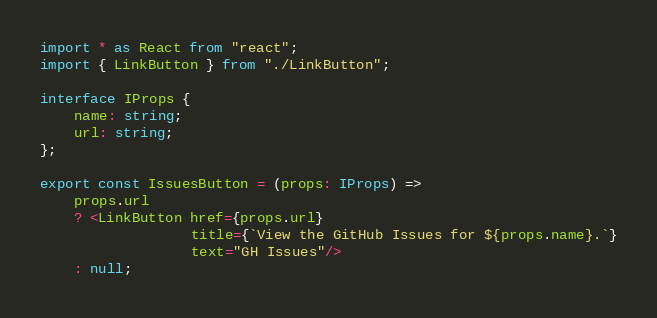<code> <loc_0><loc_0><loc_500><loc_500><_TypeScript_>import * as React from "react";
import { LinkButton } from "./LinkButton";

interface IProps {
    name: string;
    url: string;
};

export const IssuesButton = (props: IProps) =>
    props.url
    ? <LinkButton href={props.url}
                  title={`View the GitHub Issues for ${props.name}.`}
                  text="GH Issues"/>
    : null;</code> 